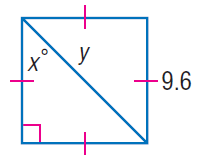Answer the mathemtical geometry problem and directly provide the correct option letter.
Question: Find x.
Choices: A: 30 B: 37.5 C: 45 D: 90 C 